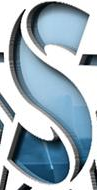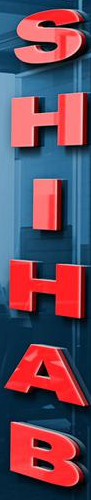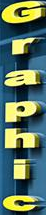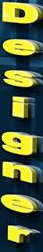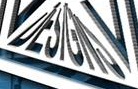What text is displayed in these images sequentially, separated by a semicolon? S; SHIHAB; Graphic; Designer; DESIGNS 